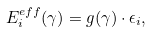<formula> <loc_0><loc_0><loc_500><loc_500>E ^ { e f f } _ { i } ( \gamma ) = g ( \gamma ) \cdot \epsilon _ { i } ,</formula> 